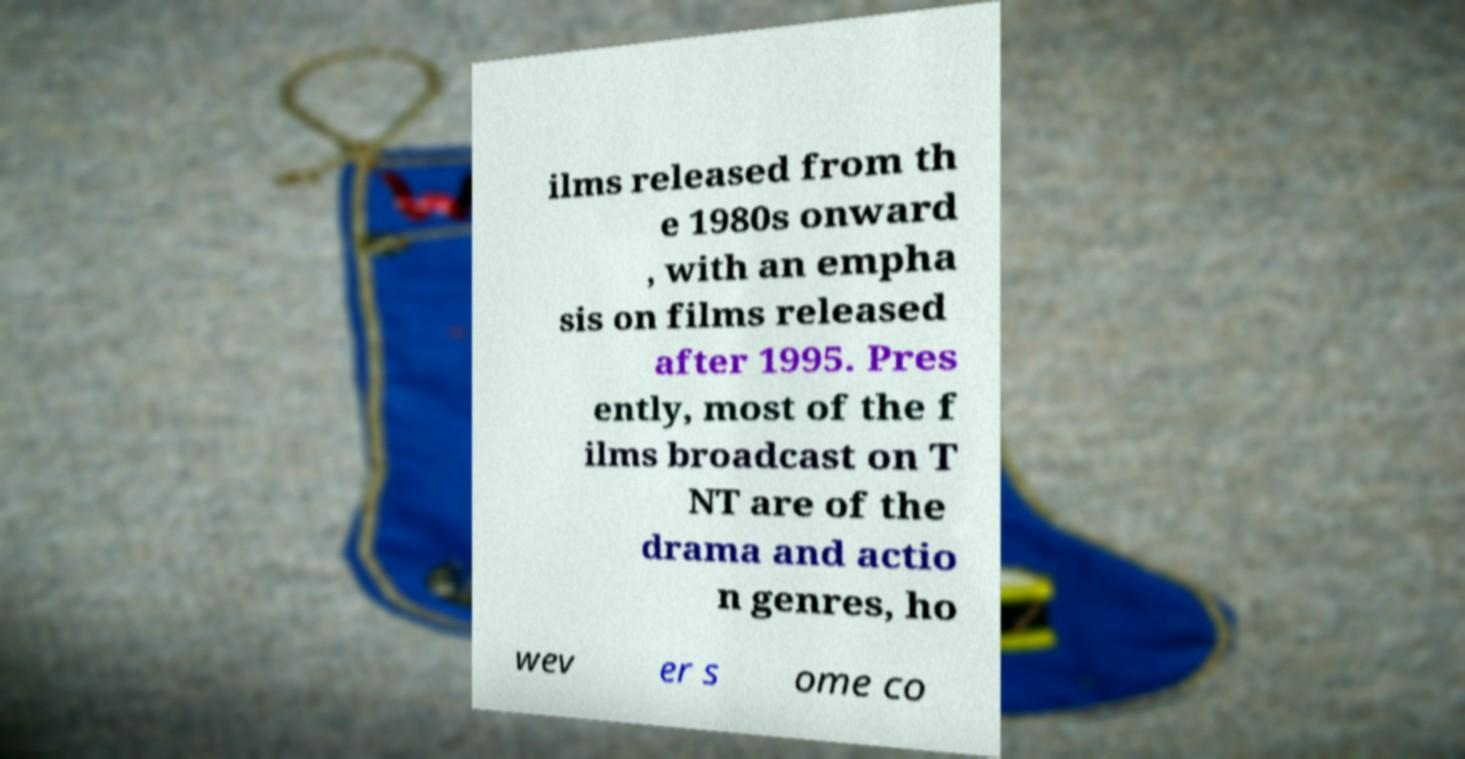What messages or text are displayed in this image? I need them in a readable, typed format. ilms released from th e 1980s onward , with an empha sis on films released after 1995. Pres ently, most of the f ilms broadcast on T NT are of the drama and actio n genres, ho wev er s ome co 